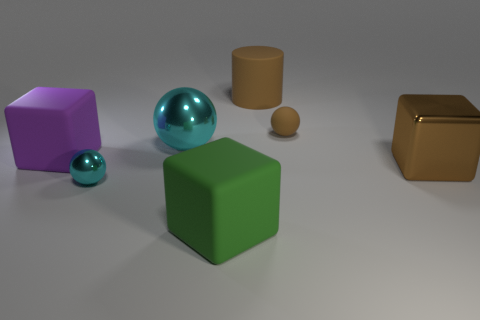Is the color of the large shiny ball the same as the small metal ball?
Give a very brief answer. Yes. There is a metallic thing to the left of the cyan ball behind the big purple matte block; how many big cyan metal spheres are right of it?
Your response must be concise. 1. What material is the cyan object behind the small ball in front of the cyan object behind the big purple matte cube made of?
Your answer should be very brief. Metal. There is a large cube on the right side of the brown rubber sphere; what material is it?
Provide a short and direct response. Metal. Is the color of the small ball that is in front of the small brown matte thing the same as the big metallic ball?
Keep it short and to the point. Yes. Is the brown metal thing the same size as the cylinder?
Your answer should be compact. Yes. What number of tiny cyan things are made of the same material as the large green block?
Your response must be concise. 0. There is another metal object that is the same shape as the small metal object; what size is it?
Your answer should be very brief. Large. There is a rubber object on the left side of the big cyan ball; is it the same shape as the green object?
Ensure brevity in your answer.  Yes. The large matte thing that is to the right of the large object that is in front of the brown metal thing is what shape?
Provide a succinct answer. Cylinder. 